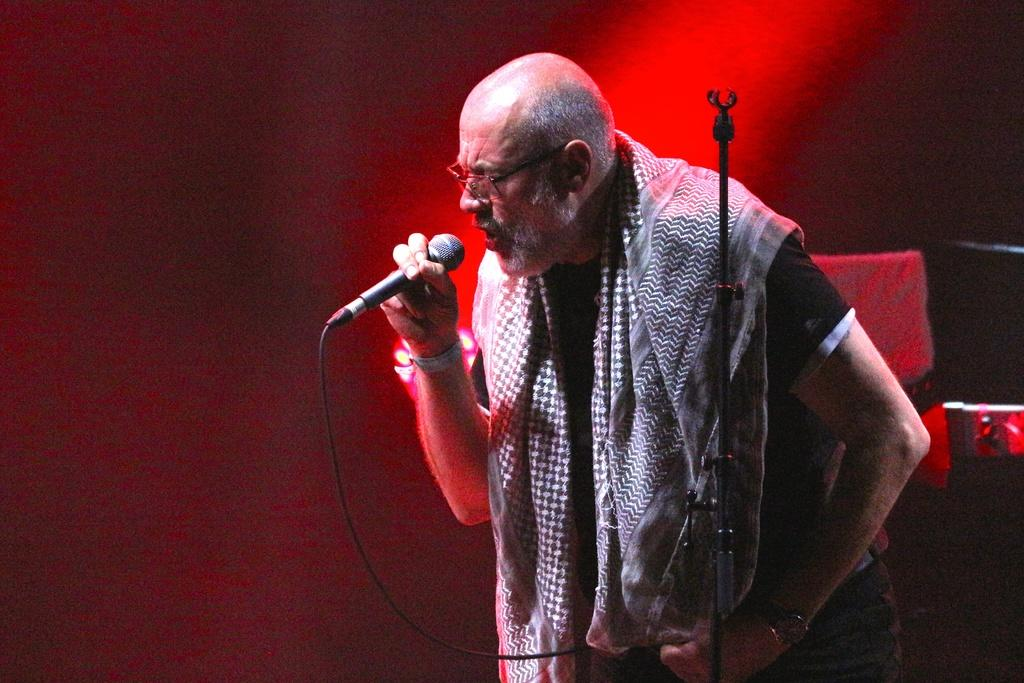What is the main subject of the image? There is a person in the image. What is the person wearing? The person is wearing a black shirt. What is the person doing in the image? The person is standing and singing. What object is the person using while singing? The person is in front of a microphone. What color is the background of the image? The background color is red. How many chairs can be seen in the image? There are no chairs visible in the image. What type of pickle is being used as a prop in the image? There is no pickle present in the image. 